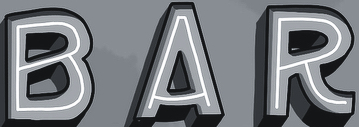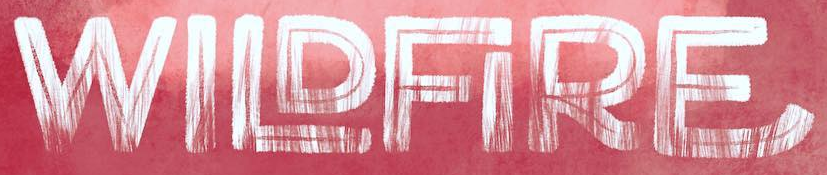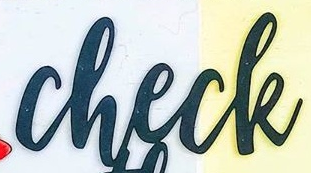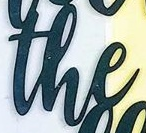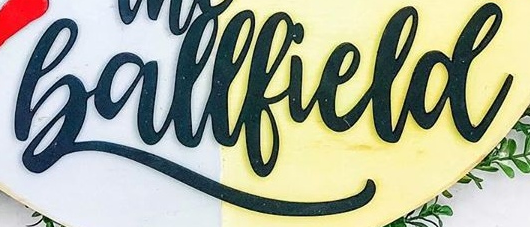Identify the words shown in these images in order, separated by a semicolon. BAR; WILDFIRE; check; the; Ballfield 